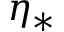Convert formula to latex. <formula><loc_0><loc_0><loc_500><loc_500>\eta _ { * }</formula> 